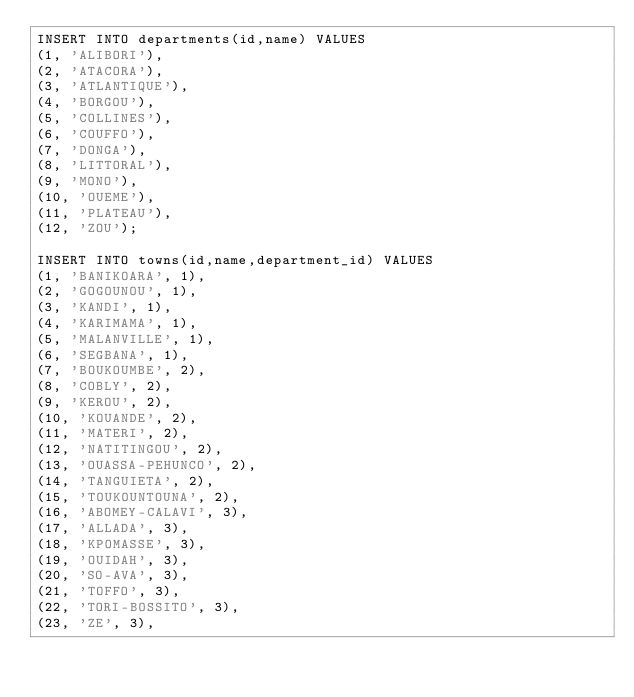Convert code to text. <code><loc_0><loc_0><loc_500><loc_500><_SQL_>INSERT INTO departments(id,name) VALUES
(1, 'ALIBORI'),
(2, 'ATACORA'),
(3, 'ATLANTIQUE'),
(4, 'BORGOU'),
(5, 'COLLINES'),
(6, 'COUFFO'),
(7, 'DONGA'),
(8, 'LITTORAL'),
(9, 'MONO'),
(10, 'OUEME'),
(11, 'PLATEAU'),
(12, 'ZOU');

INSERT INTO towns(id,name,department_id) VALUES
(1, 'BANIKOARA', 1),
(2, 'GOGOUNOU', 1),
(3, 'KANDI', 1),
(4, 'KARIMAMA', 1),
(5, 'MALANVILLE', 1),
(6, 'SEGBANA', 1),
(7, 'BOUKOUMBE', 2),
(8, 'COBLY', 2),
(9, 'KEROU', 2),
(10, 'KOUANDE', 2),
(11, 'MATERI', 2),
(12, 'NATITINGOU', 2),
(13, 'OUASSA-PEHUNCO', 2),
(14, 'TANGUIETA', 2),
(15, 'TOUKOUNTOUNA', 2),
(16, 'ABOMEY-CALAVI', 3),
(17, 'ALLADA', 3),
(18, 'KPOMASSE', 3),
(19, 'OUIDAH', 3),
(20, 'SO-AVA', 3),
(21, 'TOFFO', 3),
(22, 'TORI-BOSSITO', 3),
(23, 'ZE', 3),</code> 